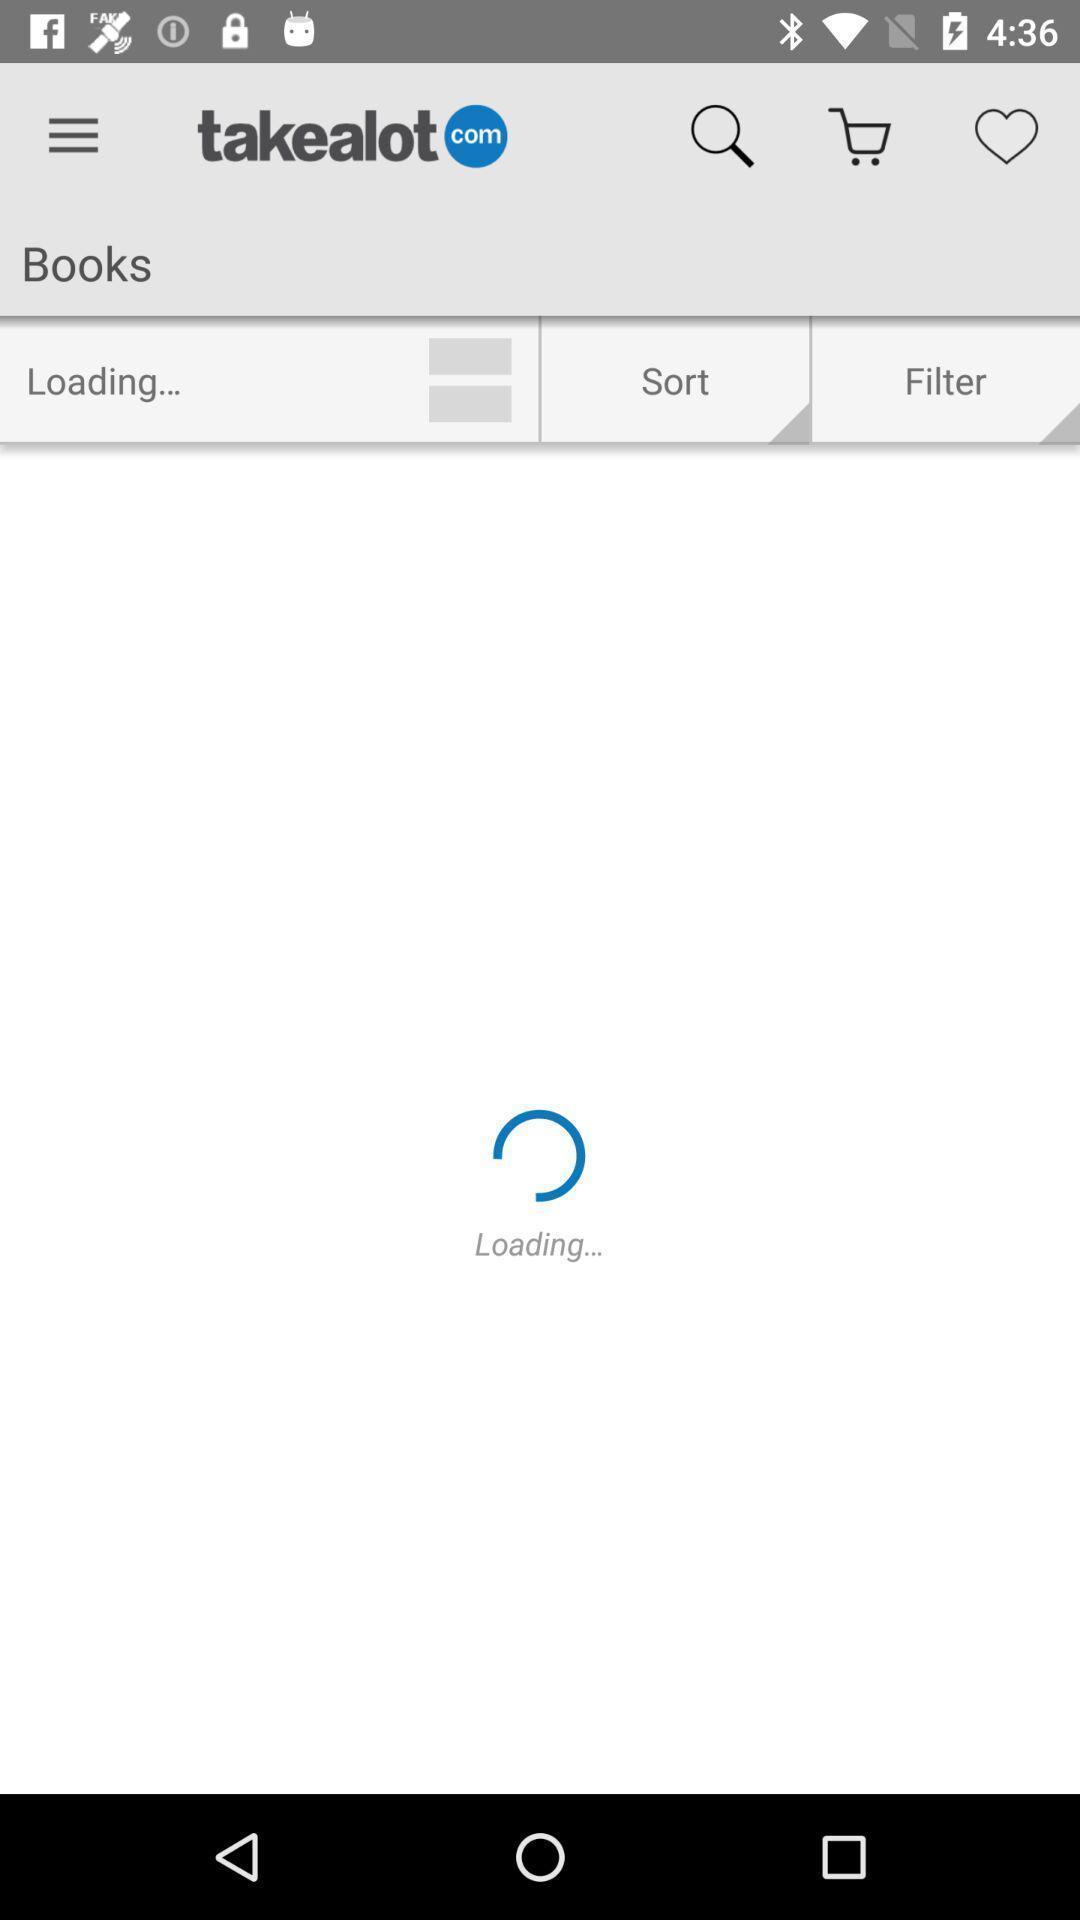Describe the content in this image. Screen shows loading status of books. 